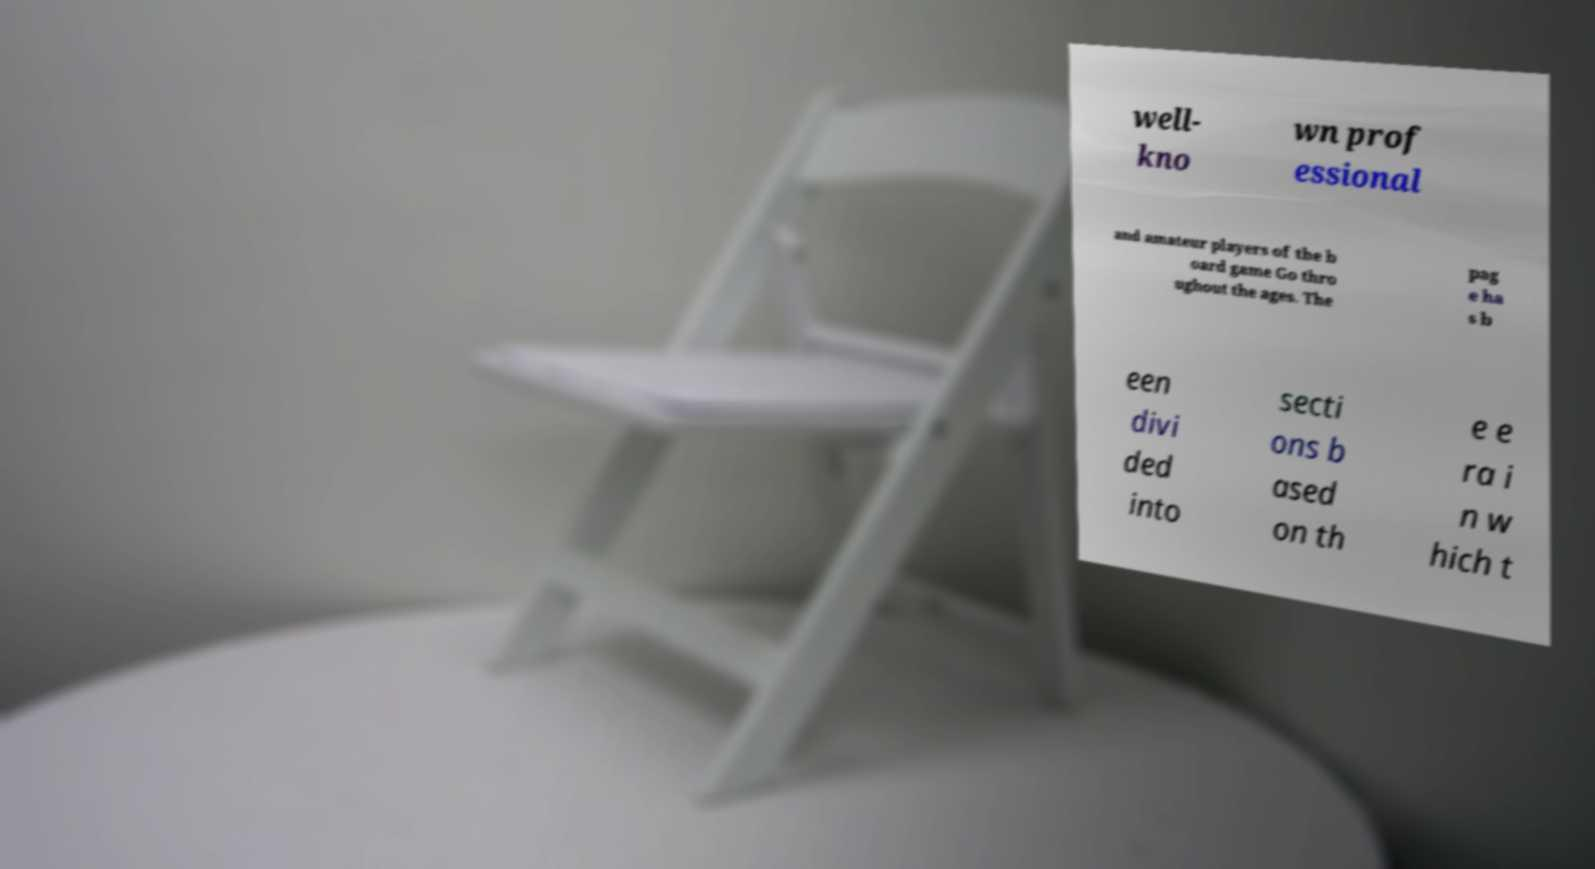Can you accurately transcribe the text from the provided image for me? well- kno wn prof essional and amateur players of the b oard game Go thro ughout the ages. The pag e ha s b een divi ded into secti ons b ased on th e e ra i n w hich t 